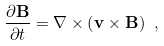Convert formula to latex. <formula><loc_0><loc_0><loc_500><loc_500>\frac { \partial { \mathbf B } } { \partial t } = \nabla \times \left ( { \mathbf v } \times { \mathbf B } \right ) \ ,</formula> 